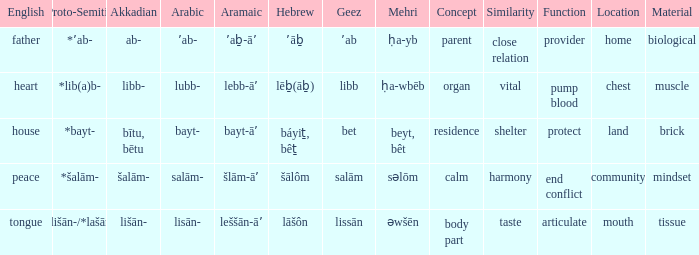If in English it's house, what is it in proto-semitic? *bayt-. Parse the table in full. {'header': ['English', 'Proto-Semitic', 'Akkadian', 'Arabic', 'Aramaic', 'Hebrew', 'Geez', 'Mehri', 'Concept', 'Similarity', 'Function', 'Location', 'Material'], 'rows': [['father', '*ʼab-', 'ab-', 'ʼab-', 'ʼaḇ-āʼ', 'ʼāḇ', 'ʼab', 'ḥa-yb', 'parent', 'close relation', 'provider', 'home', 'biological'], ['heart', '*lib(a)b-', 'libb-', 'lubb-', 'lebb-āʼ', 'lēḇ(āḇ)', 'libb', 'ḥa-wbēb', 'organ', 'vital', 'pump blood', 'chest', 'muscle'], ['house', '*bayt-', 'bītu, bētu', 'bayt-', 'bayt-āʼ', 'báyiṯ, bêṯ', 'bet', 'beyt, bêt', 'residence', 'shelter', 'protect', 'land', 'brick'], ['peace', '*šalām-', 'šalām-', 'salām-', 'šlām-āʼ', 'šālôm', 'salām', 'səlōm', 'calm', 'harmony', 'end conflict', 'community', 'mindset'], ['tongue', '*lišān-/*lašān-', 'lišān-', 'lisān-', 'leššān-āʼ', 'lāšôn', 'lissān', 'əwšēn', 'body part', 'taste', 'articulate', 'mouth', 'tissue']]} 